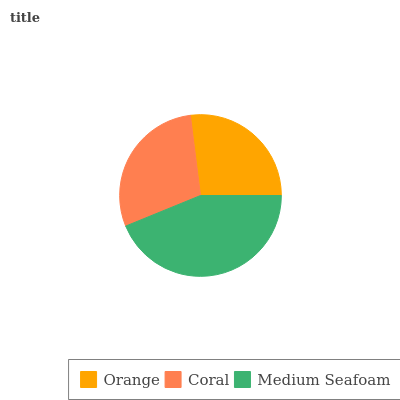Is Orange the minimum?
Answer yes or no. Yes. Is Medium Seafoam the maximum?
Answer yes or no. Yes. Is Coral the minimum?
Answer yes or no. No. Is Coral the maximum?
Answer yes or no. No. Is Coral greater than Orange?
Answer yes or no. Yes. Is Orange less than Coral?
Answer yes or no. Yes. Is Orange greater than Coral?
Answer yes or no. No. Is Coral less than Orange?
Answer yes or no. No. Is Coral the high median?
Answer yes or no. Yes. Is Coral the low median?
Answer yes or no. Yes. Is Medium Seafoam the high median?
Answer yes or no. No. Is Medium Seafoam the low median?
Answer yes or no. No. 